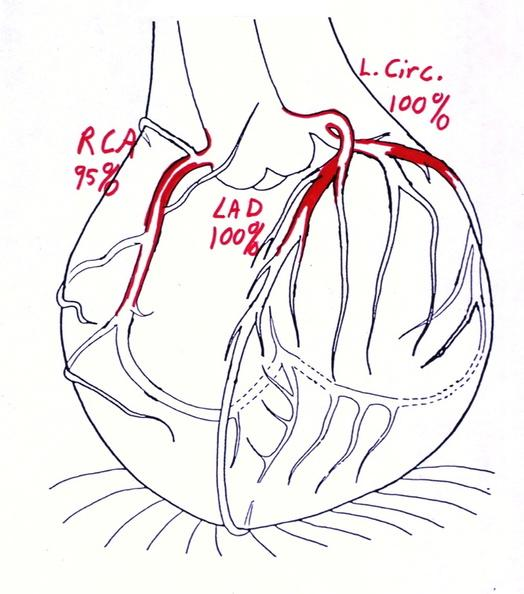what is present?
Answer the question using a single word or phrase. Cardiovascular 